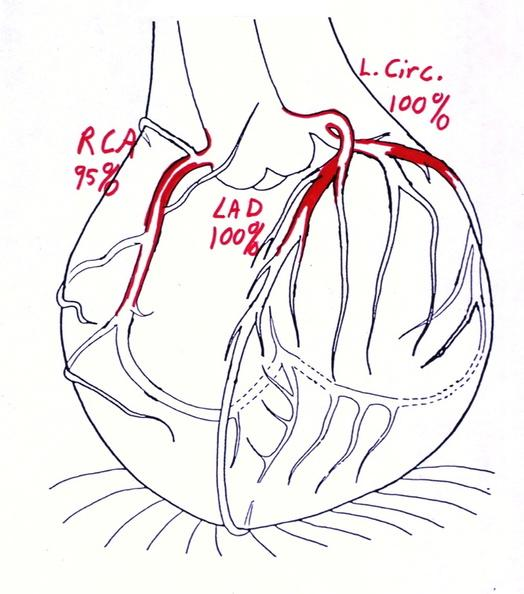what is present?
Answer the question using a single word or phrase. Cardiovascular 